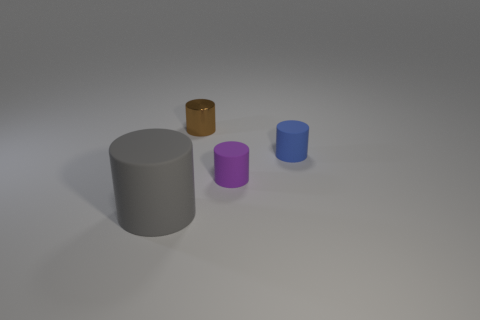Add 4 big cyan shiny spheres. How many objects exist? 8 Subtract all metallic cylinders. Subtract all small blue objects. How many objects are left? 2 Add 2 purple matte cylinders. How many purple matte cylinders are left? 3 Add 3 purple objects. How many purple objects exist? 4 Subtract 0 yellow balls. How many objects are left? 4 